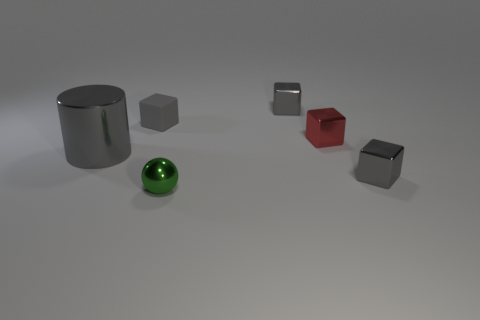Do the metal cylinder and the red metallic thing have the same size?
Give a very brief answer. No. There is a tiny gray object that is in front of the small cube on the left side of the metallic sphere; what is its material?
Your response must be concise. Metal. There is a tiny object to the left of the small green sphere; is it the same shape as the small gray shiny thing behind the large gray metal cylinder?
Offer a very short reply. Yes. Are there an equal number of gray blocks that are on the right side of the tiny red block and matte cubes?
Provide a succinct answer. Yes. Is there a gray thing that is on the right side of the small cube that is left of the tiny green sphere?
Your answer should be very brief. Yes. Is there anything else that is the same color as the shiny sphere?
Provide a succinct answer. No. Are the gray block that is in front of the matte block and the tiny red block made of the same material?
Your answer should be very brief. Yes. Is the number of large gray things right of the gray matte block the same as the number of gray shiny cylinders that are on the right side of the gray cylinder?
Offer a very short reply. Yes. What is the size of the gray metallic block in front of the shiny thing on the left side of the tiny green metal ball?
Provide a short and direct response. Small. What is the tiny thing that is in front of the red block and right of the tiny green metal thing made of?
Ensure brevity in your answer.  Metal. 